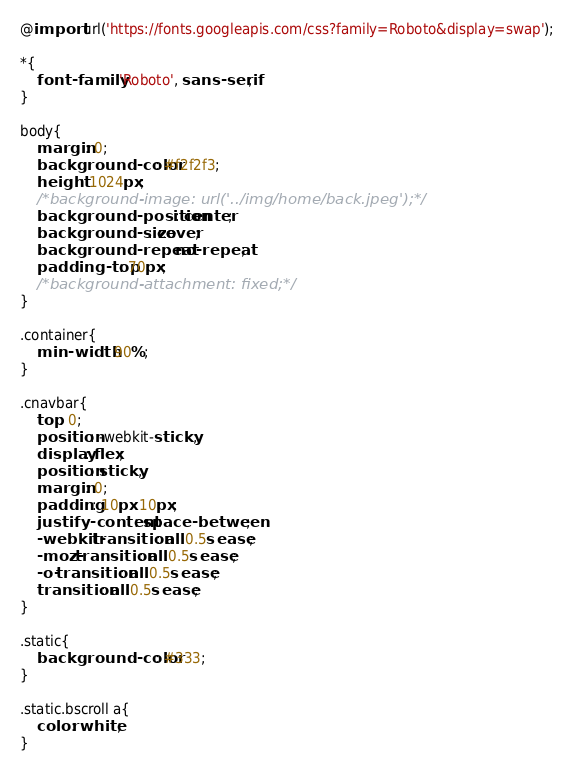<code> <loc_0><loc_0><loc_500><loc_500><_CSS_>@import url('https://fonts.googleapis.com/css?family=Roboto&display=swap');

*{
	font-family: 'Roboto', sans-serif;
}

body{
	margin: 0;
	background-color: #f2f2f3;
	height: 1024px;
	/*background-image: url('../img/home/back.jpeg');*/
	background-position: center;
	background-size: cover;
	background-repeat: no-repeat;
	padding-top: 70px;
	/*background-attachment: fixed;*/
}

.container{
	min-width: 90%;
}

.cnavbar{
	top: 0;
	position: -webkit-sticky;
	display: flex;
	position: sticky;
	margin: 0;
	padding: 10px 10px;
	justify-content: space-between;
  	-webkit-transition: all 0.5s ease;
    -moz-transition: all 0.5s ease;
    -o-transition: all 0.5s ease;
    transition: all 0.5s ease;
}

.static{
	background-color: #333;
}

.static.bscroll a{
	color: white;
}
</code> 